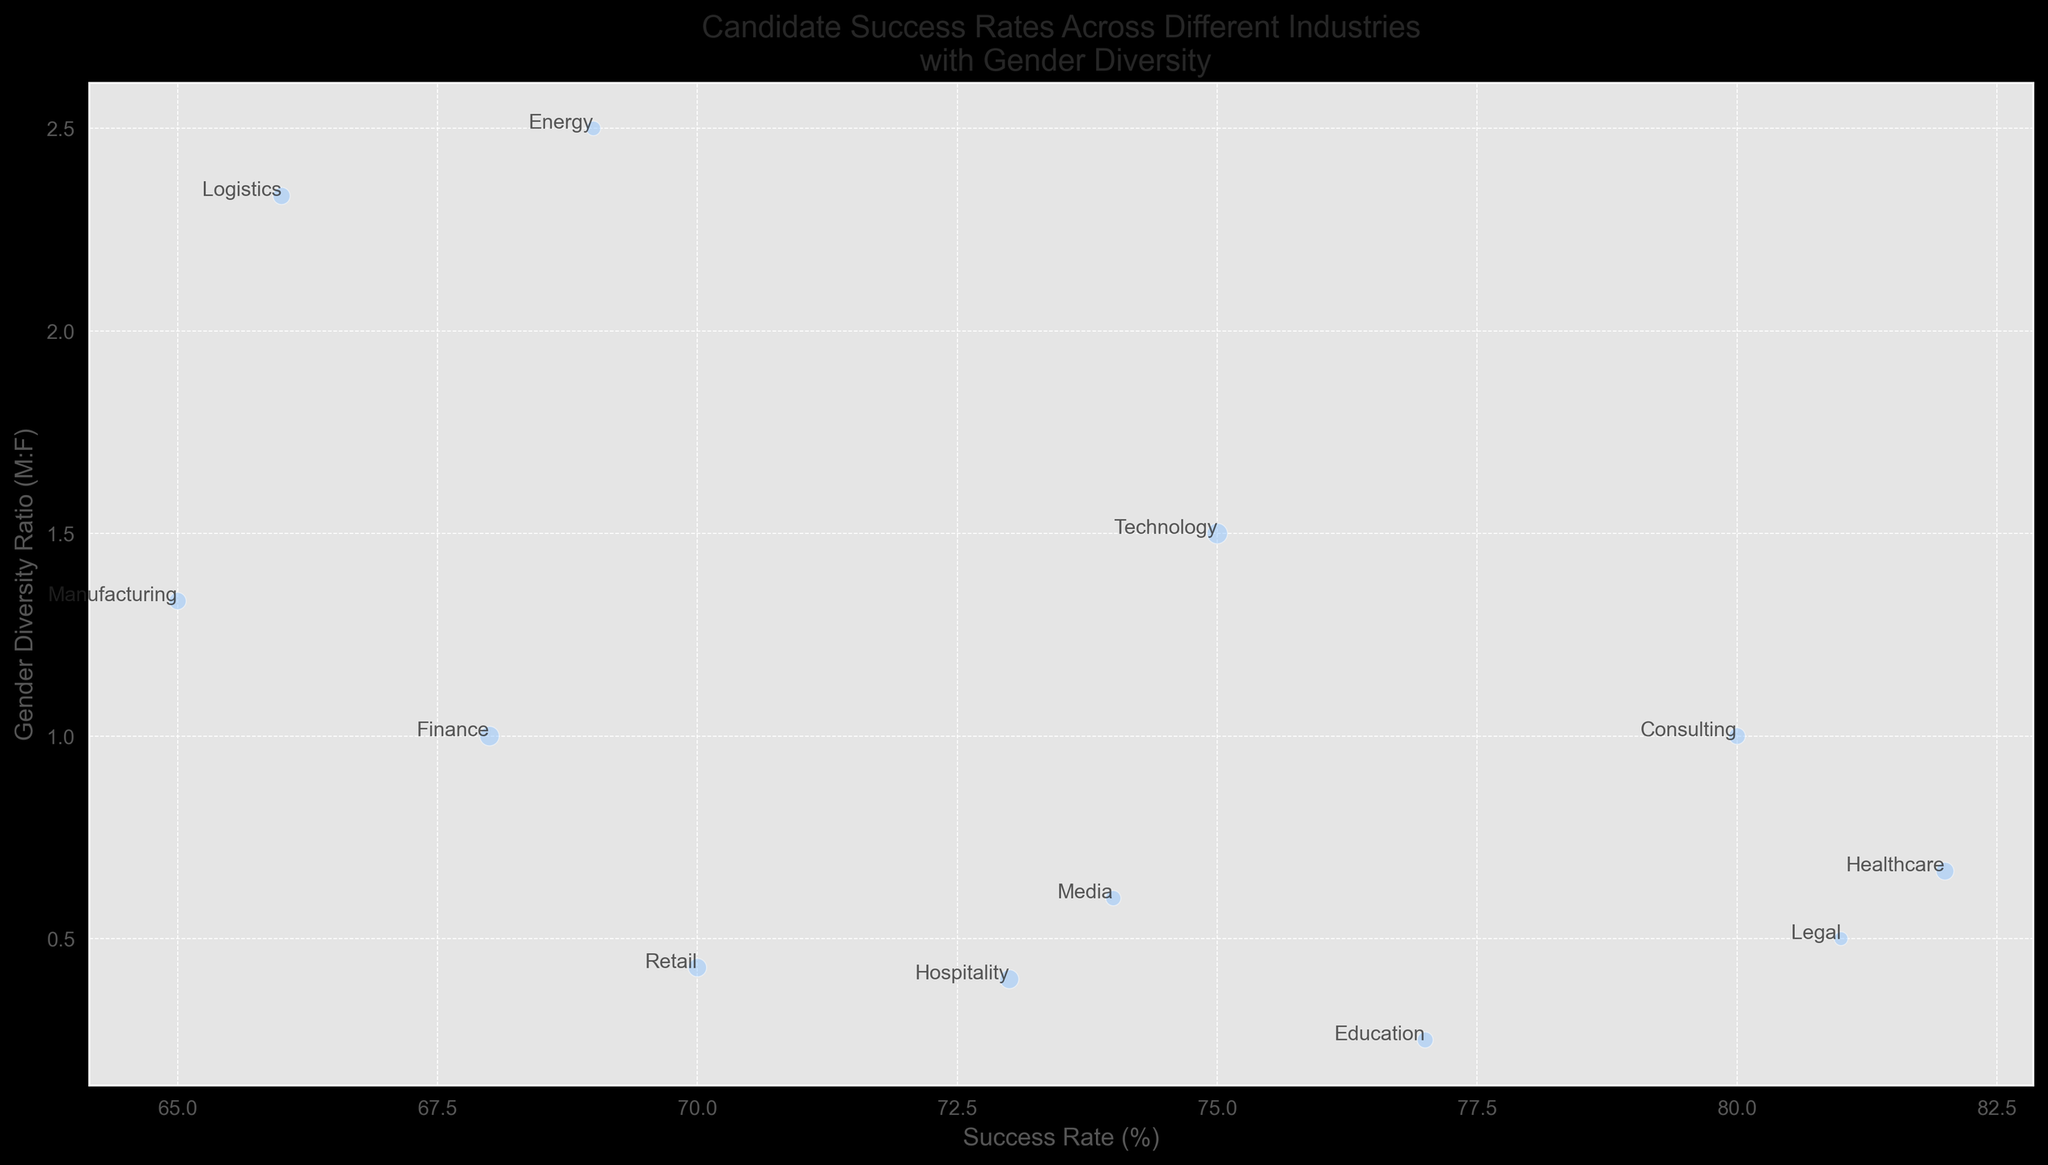Which industry has the highest candidate success rate? By observing the x-axis, Healthcare has the highest success rate of 82%
Answer: Healthcare Which industry has the lowest gender diversity ratio? By looking at the y-axis, Education has the lowest gender diversity ratio of 1:4 (0.25)
Answer: Education What is the average success rate of the Consulting, Media, and Legal industries? Add the success rates of Consulting, Media, and Legal (80 + 74 + 81) and divide by 3. (80 + 74 + 81) / 3 = 78.33
Answer: 78.33 How does the gender diversity ratio of Retail compare with that of Logistics? Retail's ratio (3:7) is lower than Logistics' ratio (7:3) since 3/7 < 7/3
Answer: Retail has a lower ratio Which industry has the largest bubble size, and what does it represent? The largest bubble size corresponds to Technology, indicating it has the highest number of candidates - 200
Answer: Technology Which industries have a gender diversity ratio greater than 1? Technology, Finance, Manufacturing, Energy, and Logistics have M:F ratios greater than 1
Answer: Technology, Finance, Manufacturing, Energy, Logistics If we combine the success rates of Technology and Finance, what would be their average success rate? Add Technology and Finance's success rates (75 + 68) and divide by 2. (75 + 68) / 2 = 71.5
Answer: 71.5 Which industry has a higher success rate: Energy or Logistics? By observing the x-axis, Energy has a higher success rate of 69% compared to Logistics' 66%
Answer: Energy What is the ratio of the number of candidates in Hospitality to those in Legal? The number of candidates in Hospitality is 170, and in Legal is 90. 170/90 = 1.89
Answer: 1.89 